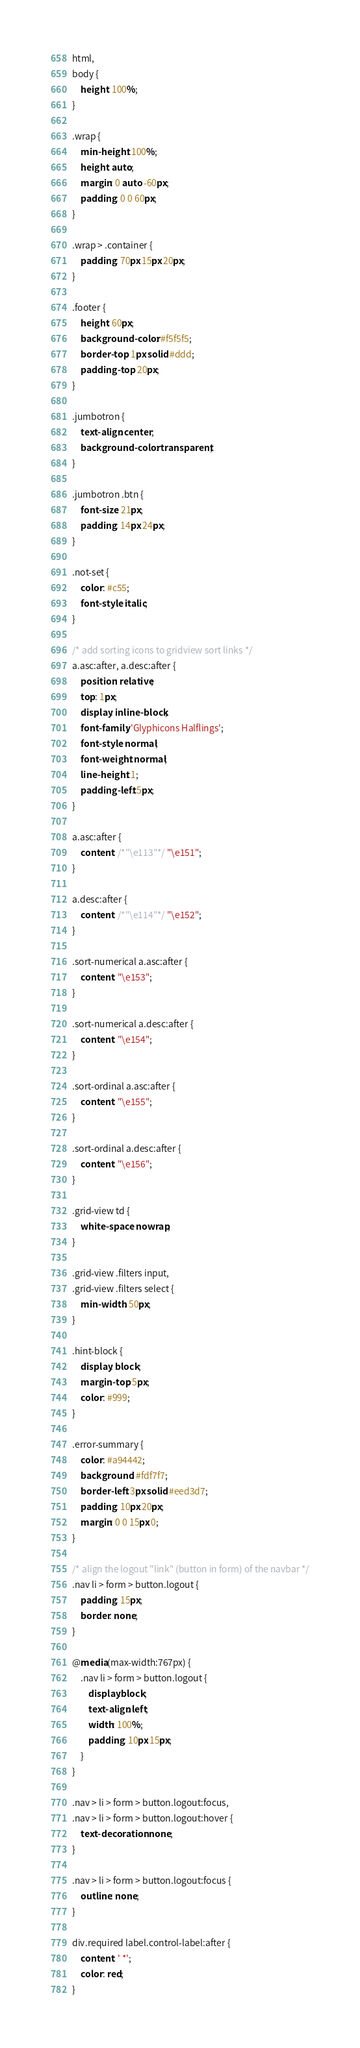Convert code to text. <code><loc_0><loc_0><loc_500><loc_500><_CSS_>html,
body {
    height: 100%;
}

.wrap {
    min-height: 100%;
    height: auto;
    margin: 0 auto -60px;
    padding: 0 0 60px;
}

.wrap > .container {
    padding: 70px 15px 20px;
}

.footer {
    height: 60px;
    background-color: #f5f5f5;
    border-top: 1px solid #ddd;
    padding-top: 20px;
}

.jumbotron {
    text-align: center;
    background-color: transparent;
}

.jumbotron .btn {
    font-size: 21px;
    padding: 14px 24px;
}

.not-set {
    color: #c55;
    font-style: italic;
}

/* add sorting icons to gridview sort links */
a.asc:after, a.desc:after {
    position: relative;
    top: 1px;
    display: inline-block;
    font-family: 'Glyphicons Halflings';
    font-style: normal;
    font-weight: normal;
    line-height: 1;
    padding-left: 5px;
}

a.asc:after {
    content: /*"\e113"*/ "\e151";
}

a.desc:after {
    content: /*"\e114"*/ "\e152";
}

.sort-numerical a.asc:after {
    content: "\e153";
}

.sort-numerical a.desc:after {
    content: "\e154";
}

.sort-ordinal a.asc:after {
    content: "\e155";
}

.sort-ordinal a.desc:after {
    content: "\e156";
}

.grid-view td {
    white-space: nowrap;
}

.grid-view .filters input,
.grid-view .filters select {
    min-width: 50px;
}

.hint-block {
    display: block;
    margin-top: 5px;
    color: #999;
}

.error-summary {
    color: #a94442;
    background: #fdf7f7;
    border-left: 3px solid #eed3d7;
    padding: 10px 20px;
    margin: 0 0 15px 0;
}

/* align the logout "link" (button in form) of the navbar */
.nav li > form > button.logout {
    padding: 15px;
    border: none;
}

@media(max-width:767px) {
    .nav li > form > button.logout {
        display:block;
        text-align: left;
        width: 100%;
        padding: 10px 15px;
    }
}

.nav > li > form > button.logout:focus,
.nav > li > form > button.logout:hover {
    text-decoration: none;
}

.nav > li > form > button.logout:focus {
    outline: none;
}

div.required label.control-label:after {
    content: ' *';
    color: red;
}
</code> 